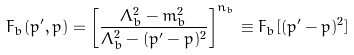Convert formula to latex. <formula><loc_0><loc_0><loc_500><loc_500>F _ { b } ( p ^ { \prime } , p ) = \left [ \frac { \Lambda _ { b } ^ { 2 } - m _ { b } ^ { 2 } } { \Lambda _ { b } ^ { 2 } - ( p ^ { \prime } - p ) ^ { 2 } } \right ] ^ { n _ { b } } \equiv F _ { b } [ ( p ^ { \prime } - p ) ^ { 2 } ]</formula> 